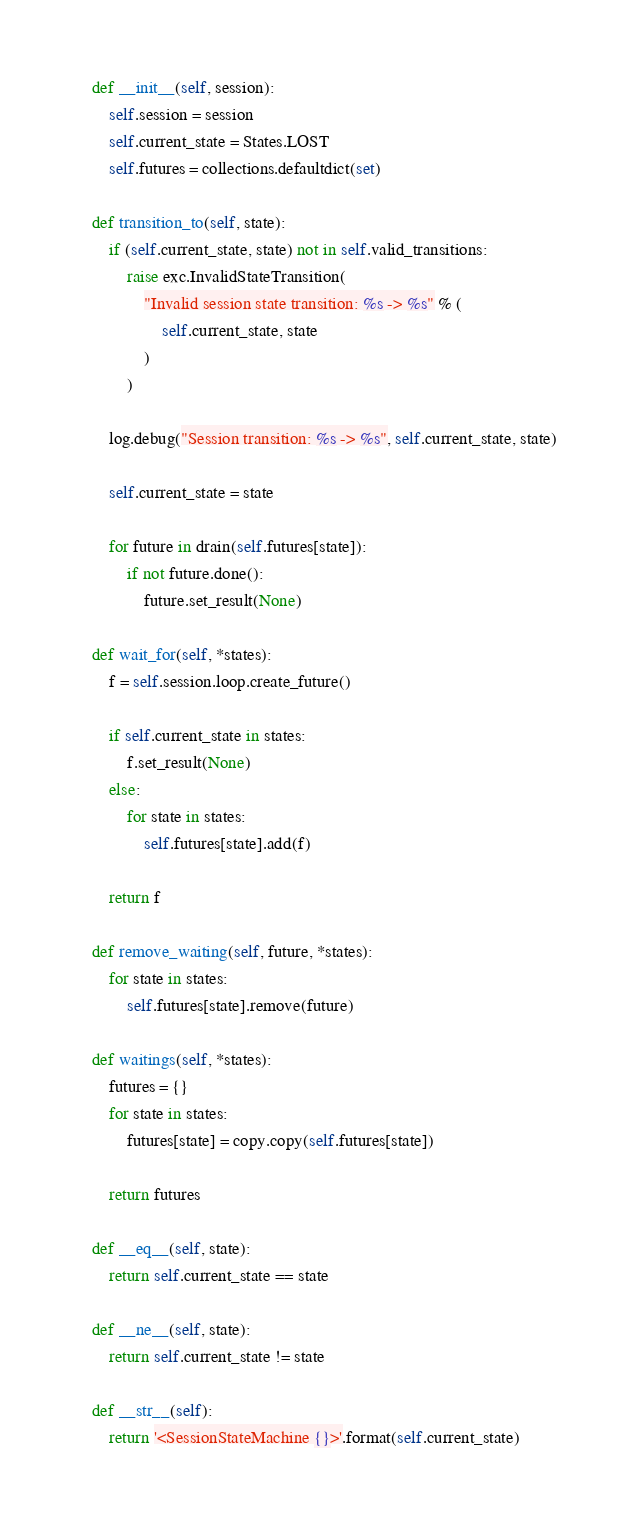<code> <loc_0><loc_0><loc_500><loc_500><_Python_>
    def __init__(self, session):
        self.session = session
        self.current_state = States.LOST
        self.futures = collections.defaultdict(set)

    def transition_to(self, state):
        if (self.current_state, state) not in self.valid_transitions:
            raise exc.InvalidStateTransition(
                "Invalid session state transition: %s -> %s" % (
                    self.current_state, state
                )
            )

        log.debug("Session transition: %s -> %s", self.current_state, state)

        self.current_state = state

        for future in drain(self.futures[state]):
            if not future.done():
                future.set_result(None)

    def wait_for(self, *states):
        f = self.session.loop.create_future()

        if self.current_state in states:
            f.set_result(None)
        else:
            for state in states:
                self.futures[state].add(f)

        return f

    def remove_waiting(self, future, *states):
        for state in states:
            self.futures[state].remove(future)

    def waitings(self, *states):
        futures = {}
        for state in states:
            futures[state] = copy.copy(self.futures[state])

        return futures

    def __eq__(self, state):
        return self.current_state == state

    def __ne__(self, state):
        return self.current_state != state

    def __str__(self):
        return '<SessionStateMachine {}>'.format(self.current_state)
</code> 